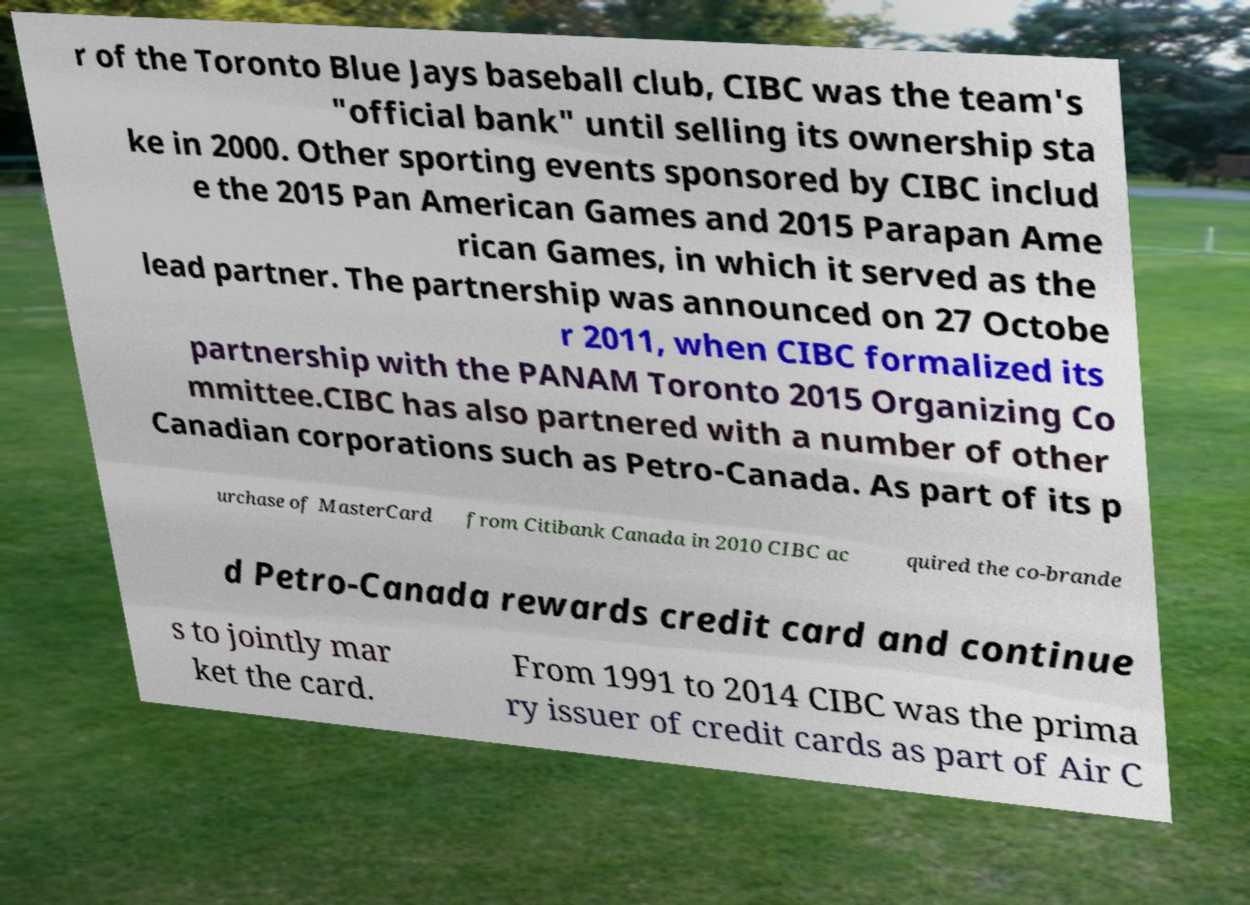Could you assist in decoding the text presented in this image and type it out clearly? r of the Toronto Blue Jays baseball club, CIBC was the team's "official bank" until selling its ownership sta ke in 2000. Other sporting events sponsored by CIBC includ e the 2015 Pan American Games and 2015 Parapan Ame rican Games, in which it served as the lead partner. The partnership was announced on 27 Octobe r 2011, when CIBC formalized its partnership with the PANAM Toronto 2015 Organizing Co mmittee.CIBC has also partnered with a number of other Canadian corporations such as Petro-Canada. As part of its p urchase of MasterCard from Citibank Canada in 2010 CIBC ac quired the co-brande d Petro-Canada rewards credit card and continue s to jointly mar ket the card. From 1991 to 2014 CIBC was the prima ry issuer of credit cards as part of Air C 